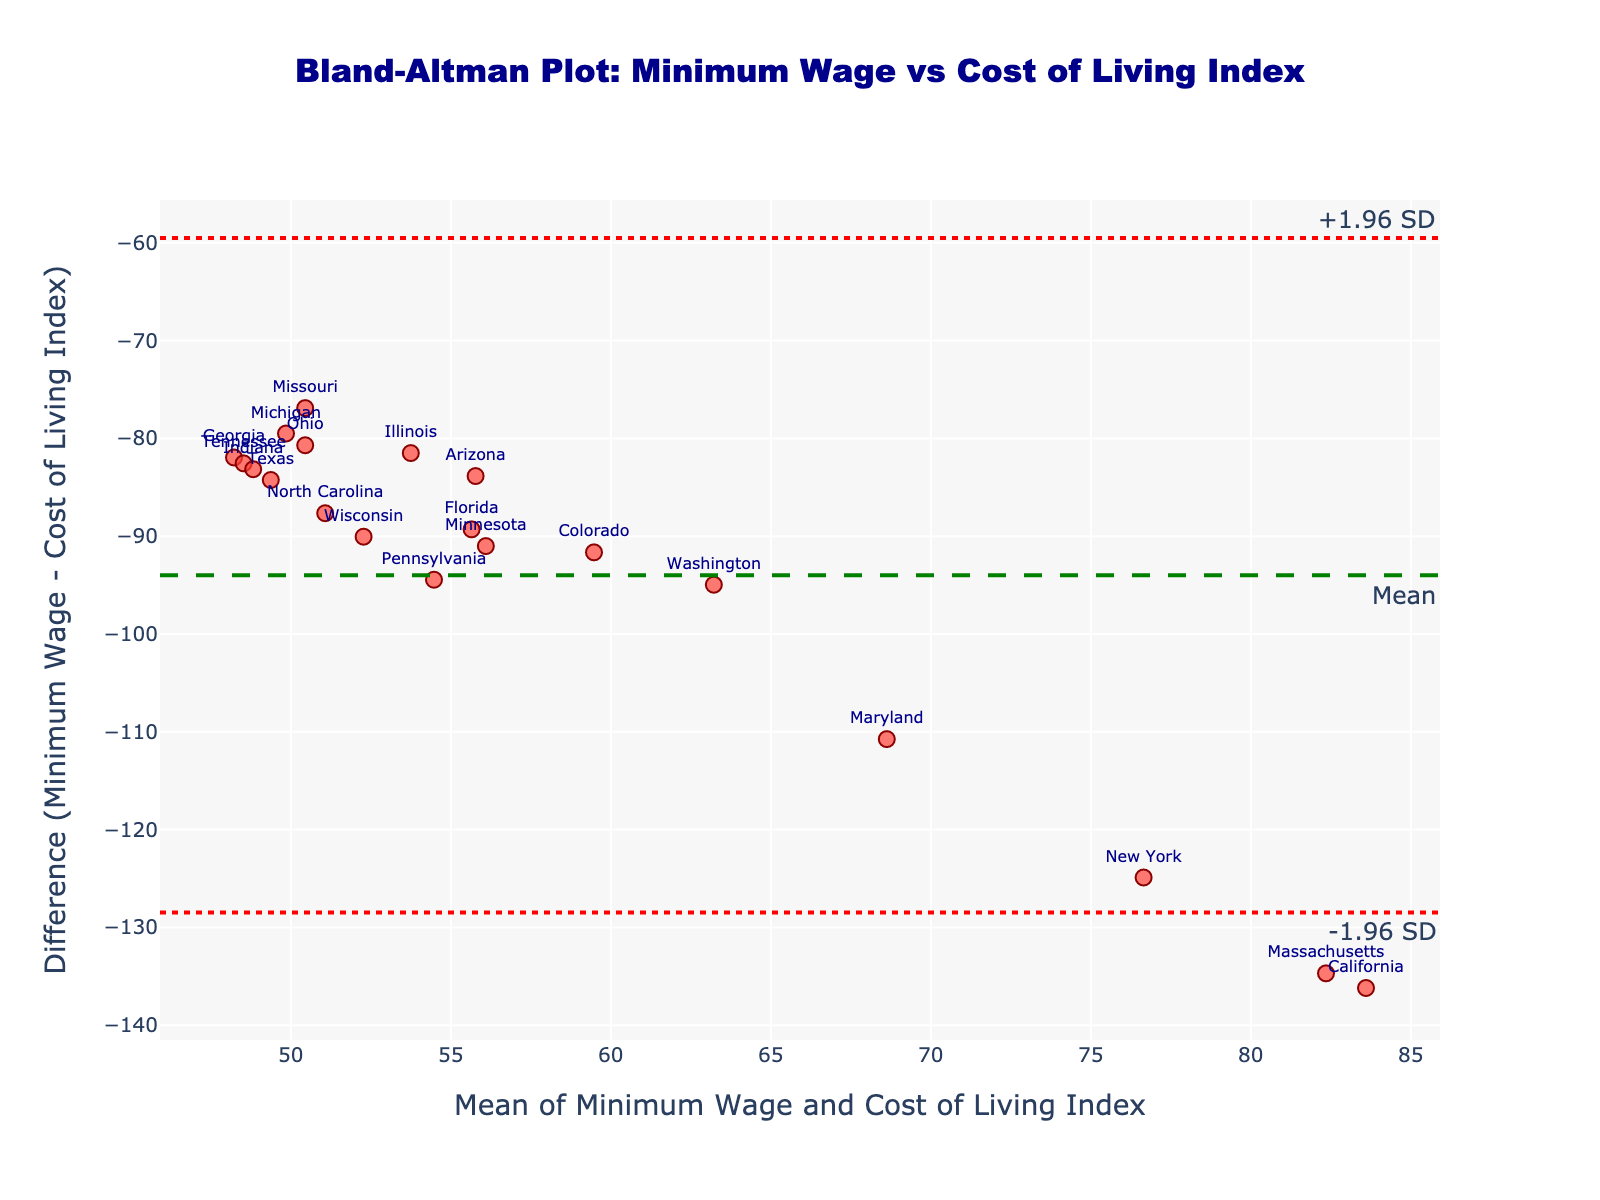How many states are represented in the plot? Each state is represented by a data point. Count the number of data points mentioned. Here, it’s the same as counting items in the dataset.
Answer: 19 What is the title of the Bland-Altman plot? Look at the title text displayed prominently at the top of the plot.
Answer: Bland-Altman Plot: Minimum Wage vs Cost of Living Index What do the dashed and dotted lines in the plot represent? There are three horizontal lines in the plot. The dashed line represents the mean difference, while the dotted lines represent the upper and lower limits of agreement (+1.96 SD and -1.96 SD).
Answer: The dashed line is the Mean; the dotted lines are +1.96 SD and -1.96 SD Which state has the highest positive difference between Minimum Wage and Cost of Living Index? Look for the data point with the highest positive y-value (difference) and identify the corresponding state from the text labels.
Answer: Washington Which states have a minimum wage of $7.25? Identify data points that are near the lower end of the x-axis and check their text labels.
Answer: Texas, Pennsylvania, Georgia, North Carolina, Tennessee, Indiana, Wisconsin What is the average difference (Minimum Wage - Cost of Living Index) for all states? The average difference is denoted by the horizontal dashed green line. Estimate the y-value of this line.
Answer: Approximately -81 Which state has a Cost of Living Index closest to 100? Identify the data point on the x-axis (mean) closest to 100 + Minimum Wage / 2, and note the text label.
Answer: Florida Which two states have the most similar average values (mean of Minimum Wage and Cost of Living Index)? Compare the x-values (means) of data points and look for those closest to each other, then check their labels.
Answer: Pennsylvania and Minnesota Which state has the largest negative difference (Minimum Wage - Cost of Living Index)? Look for the data point with the lowest (most negative) y-value (difference), and identify the corresponding state from the text labels.
Answer: California 